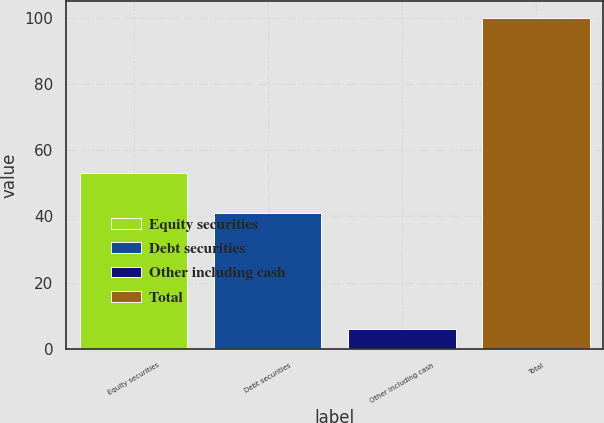Convert chart to OTSL. <chart><loc_0><loc_0><loc_500><loc_500><bar_chart><fcel>Equity securities<fcel>Debt securities<fcel>Other including cash<fcel>Total<nl><fcel>53<fcel>41<fcel>6<fcel>100<nl></chart> 